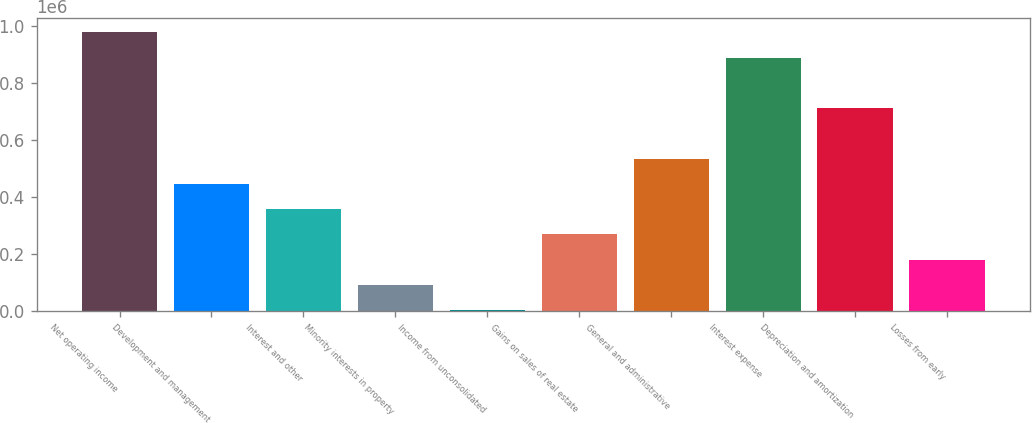Convert chart to OTSL. <chart><loc_0><loc_0><loc_500><loc_500><bar_chart><fcel>Net operating income<fcel>Development and management<fcel>Interest and other<fcel>Minority interests in property<fcel>Income from unconsolidated<fcel>Gains on sales of real estate<fcel>General and administrative<fcel>Interest expense<fcel>Depreciation and amortization<fcel>Losses from early<nl><fcel>978440<fcel>446589<fcel>357947<fcel>92021.8<fcel>3380<fcel>269305<fcel>535231<fcel>889798<fcel>712514<fcel>180664<nl></chart> 